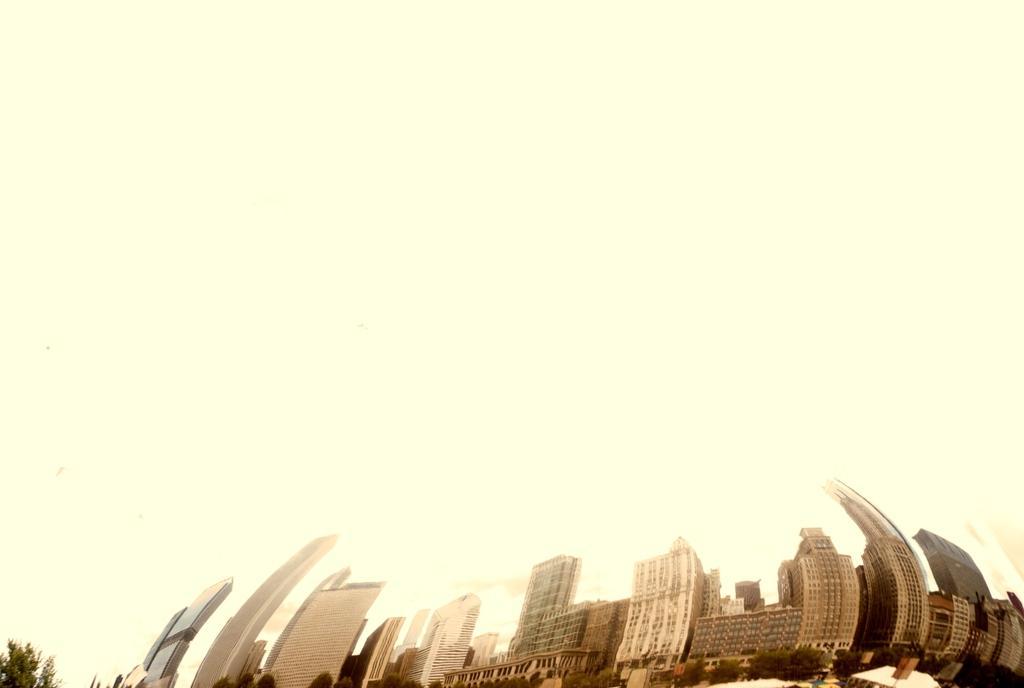Could you give a brief overview of what you see in this image? In this image in the front there are buildings and trees. 